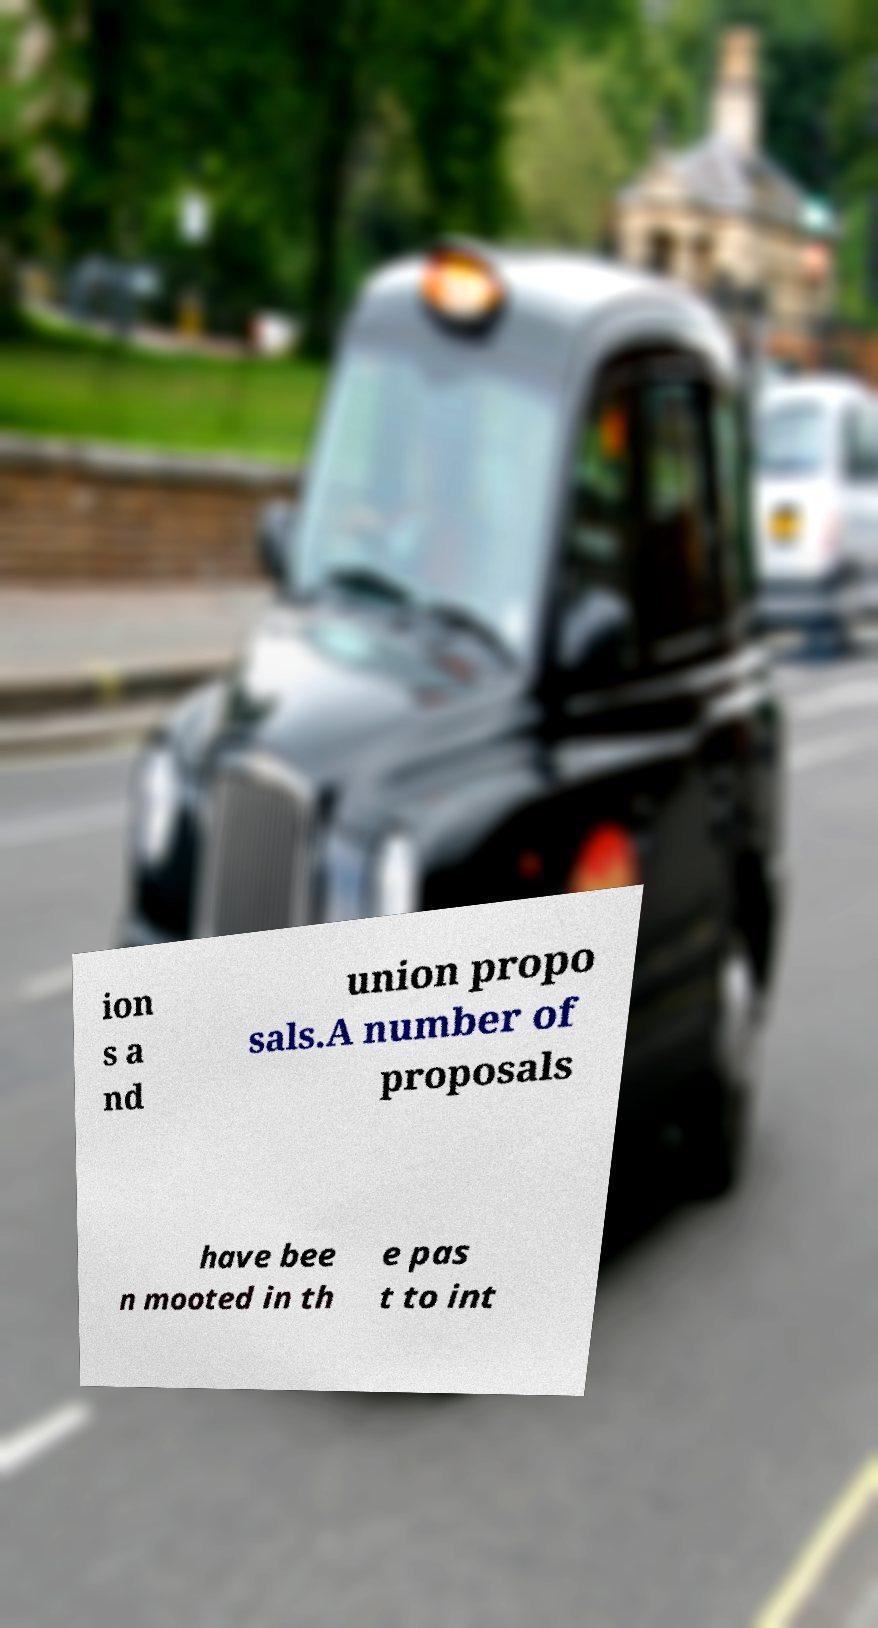Could you assist in decoding the text presented in this image and type it out clearly? ion s a nd union propo sals.A number of proposals have bee n mooted in th e pas t to int 